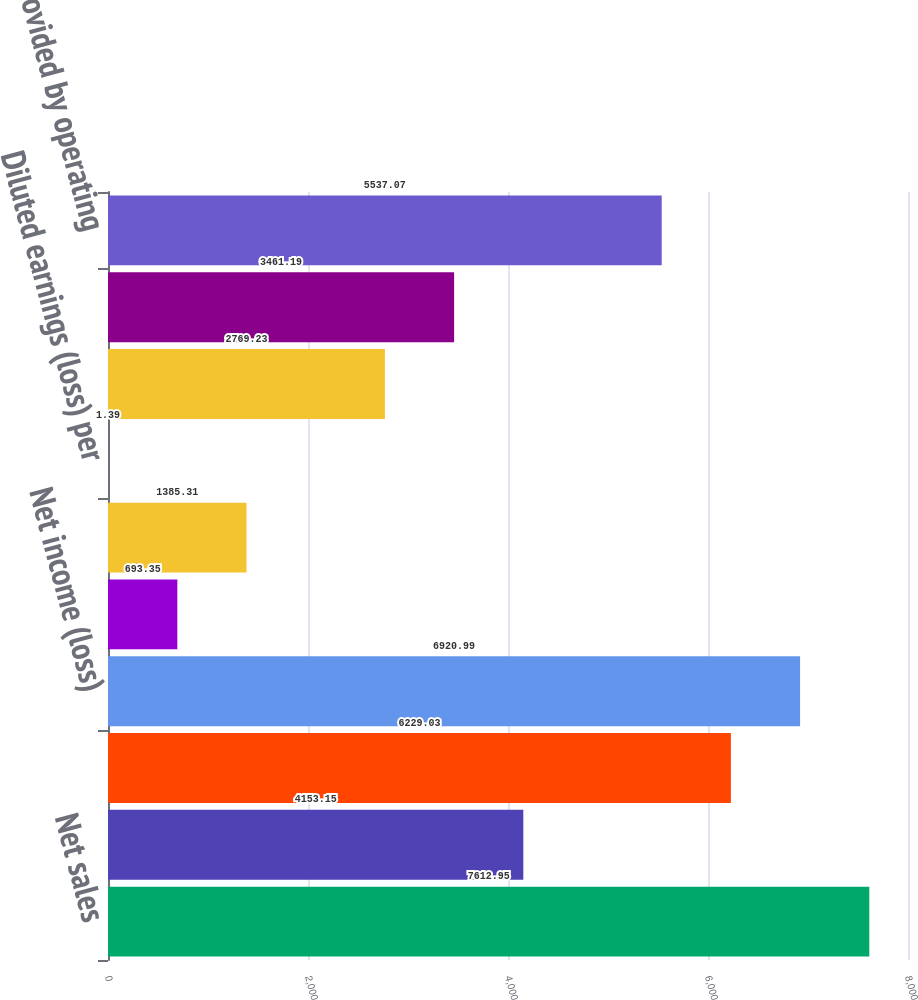Convert chart. <chart><loc_0><loc_0><loc_500><loc_500><bar_chart><fcel>Net sales<fcel>Income from operations<fcel>Income (loss) before change in<fcel>Net income (loss)<fcel>Prior to cumulative effect of<fcel>Basic earnings (loss) per<fcel>Diluted earnings (loss) per<fcel>Basic<fcel>Diluted<fcel>Net cash provided by operating<nl><fcel>7612.95<fcel>4153.15<fcel>6229.03<fcel>6920.99<fcel>693.35<fcel>1385.31<fcel>1.39<fcel>2769.23<fcel>3461.19<fcel>5537.07<nl></chart> 